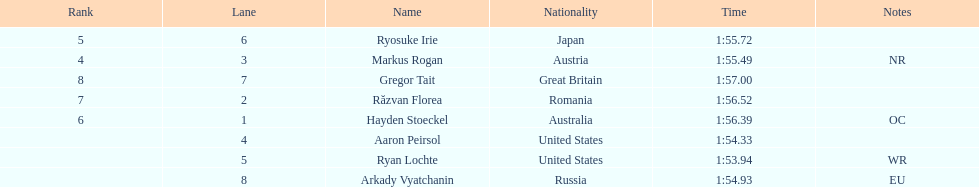How many names are listed? 8. 